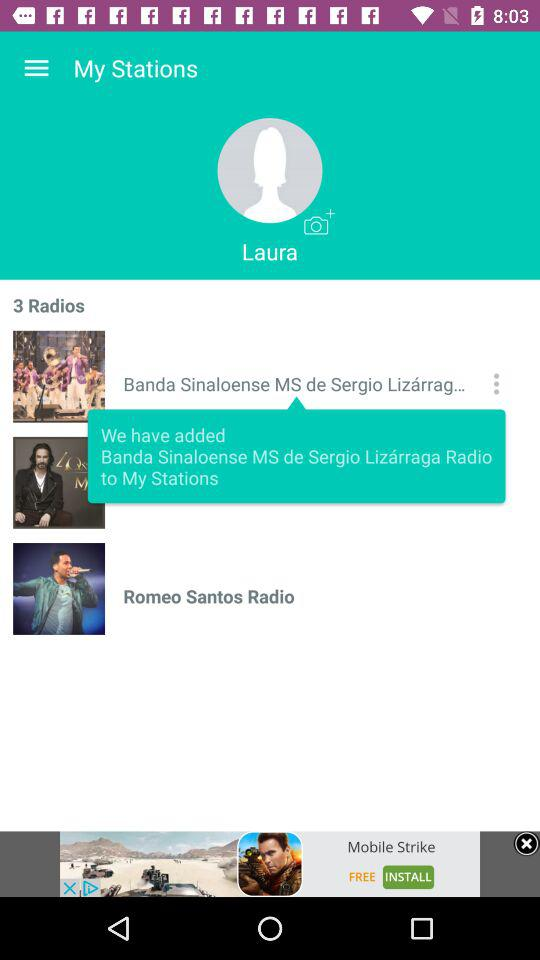What's the added radio station name? The added radio station name is "Banda Sinaloense MS de Sergio Lizárraga Radio". 